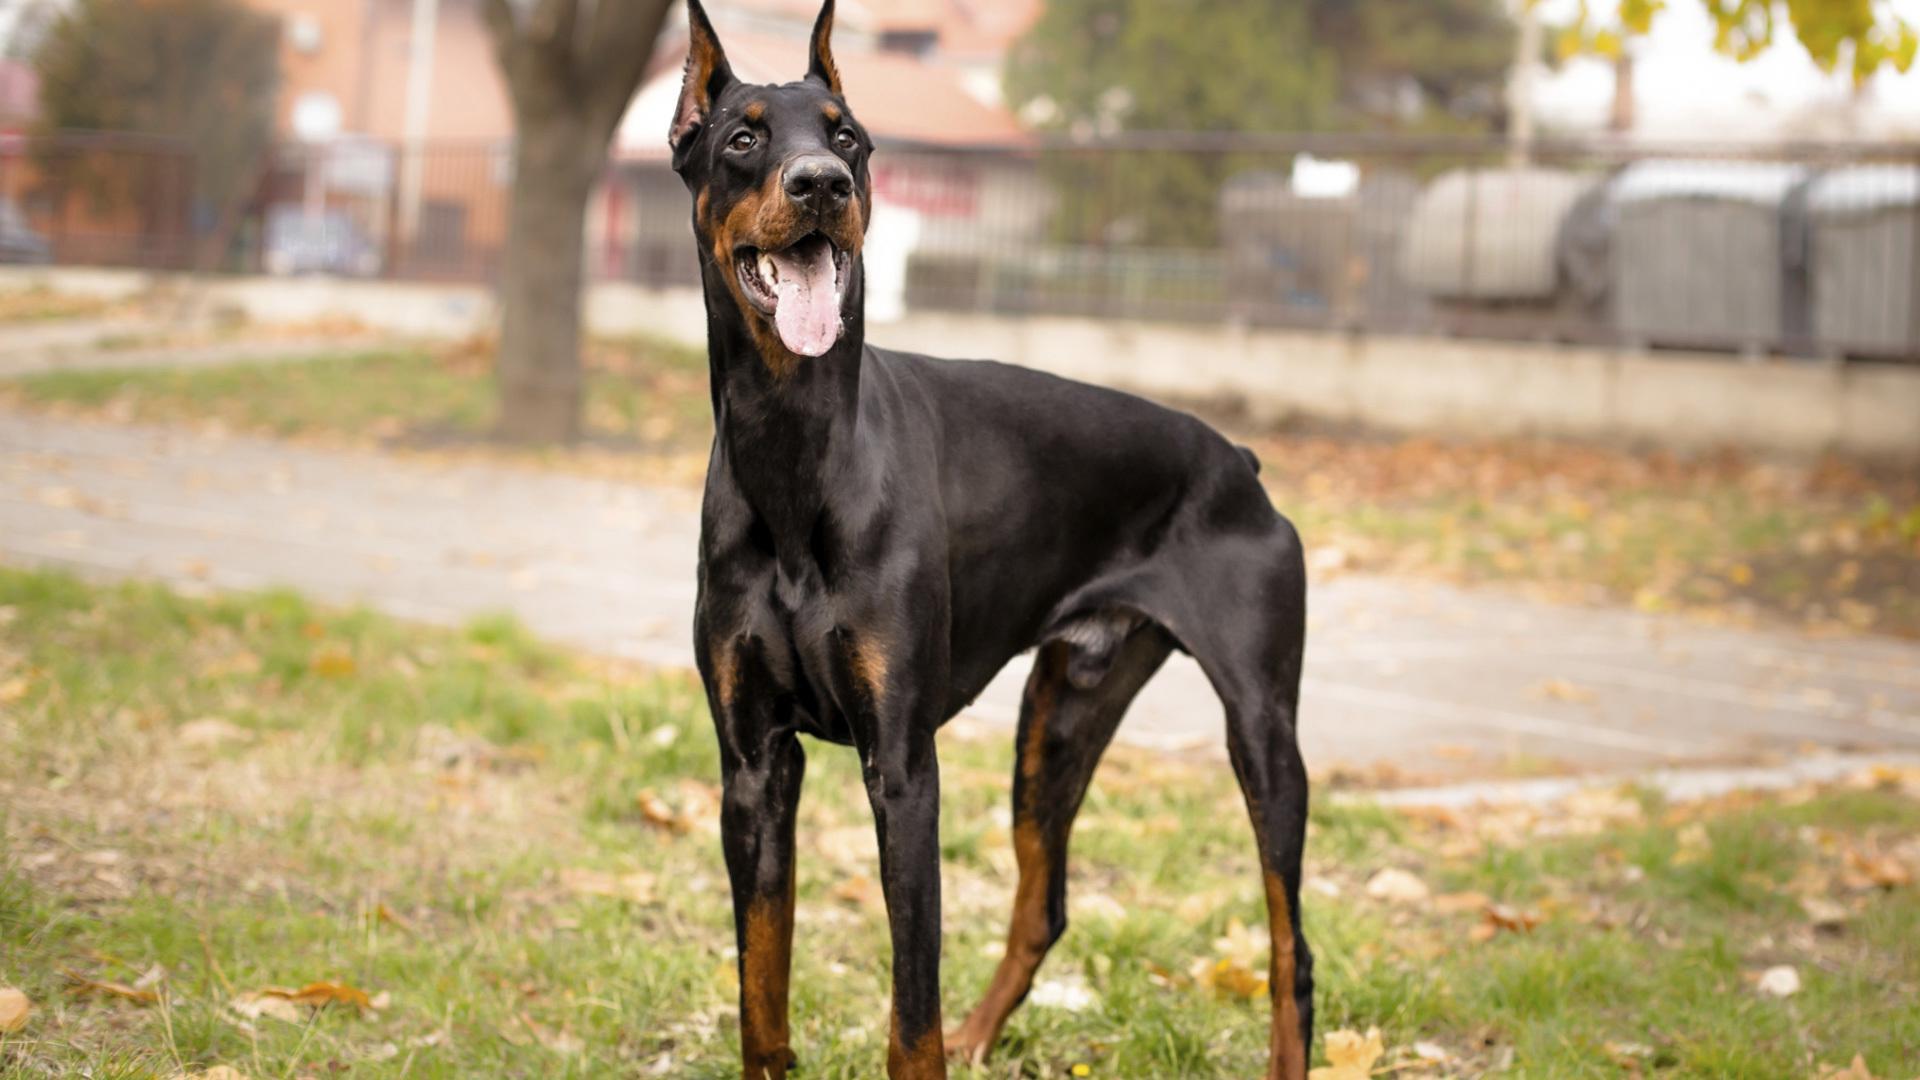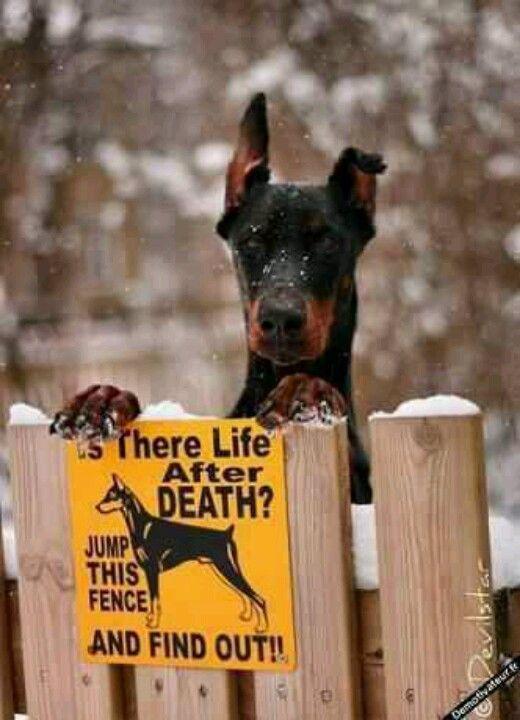The first image is the image on the left, the second image is the image on the right. Analyze the images presented: Is the assertion "One doberman has its front paws on a fence." valid? Answer yes or no. Yes. The first image is the image on the left, the second image is the image on the right. Analyze the images presented: Is the assertion "One image features a doberman with its front paws over the edge of a wooden fence." valid? Answer yes or no. Yes. 